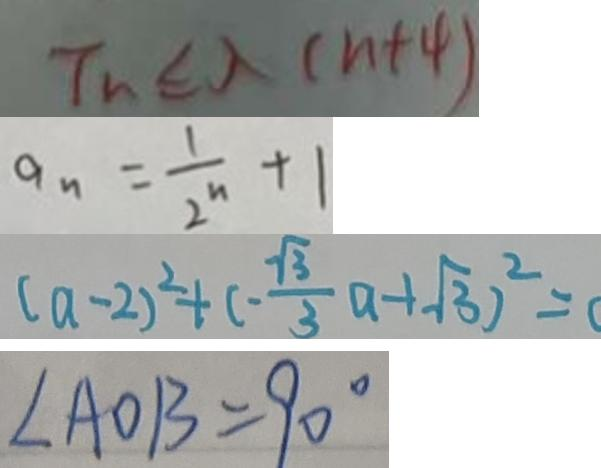<formula> <loc_0><loc_0><loc_500><loc_500>T _ { n } \epsilon \lambda ( n + 4 ) 
 a _ { n } = \frac { 1 } { 2 ^ { n } } + 1 
 ( a - 2 ) ^ { 2 } + ( - \frac { \sqrt { 3 } } { 3 } a - 1 \sqrt { 3 } ) ^ { 2 } = ( 
 \angle A O B = 9 0 ^ { \circ }</formula> 